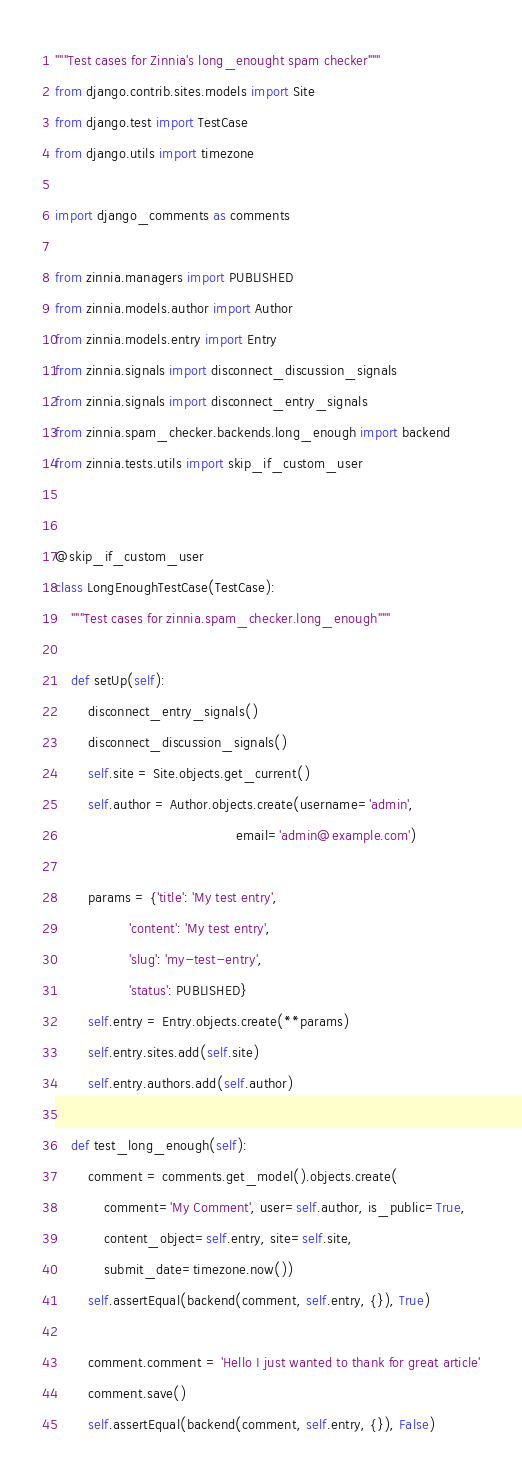Convert code to text. <code><loc_0><loc_0><loc_500><loc_500><_Python_>"""Test cases for Zinnia's long_enought spam checker"""
from django.contrib.sites.models import Site
from django.test import TestCase
from django.utils import timezone

import django_comments as comments

from zinnia.managers import PUBLISHED
from zinnia.models.author import Author
from zinnia.models.entry import Entry
from zinnia.signals import disconnect_discussion_signals
from zinnia.signals import disconnect_entry_signals
from zinnia.spam_checker.backends.long_enough import backend
from zinnia.tests.utils import skip_if_custom_user


@skip_if_custom_user
class LongEnoughTestCase(TestCase):
    """Test cases for zinnia.spam_checker.long_enough"""

    def setUp(self):
        disconnect_entry_signals()
        disconnect_discussion_signals()
        self.site = Site.objects.get_current()
        self.author = Author.objects.create(username='admin',
                                            email='admin@example.com')

        params = {'title': 'My test entry',
                  'content': 'My test entry',
                  'slug': 'my-test-entry',
                  'status': PUBLISHED}
        self.entry = Entry.objects.create(**params)
        self.entry.sites.add(self.site)
        self.entry.authors.add(self.author)

    def test_long_enough(self):
        comment = comments.get_model().objects.create(
            comment='My Comment', user=self.author, is_public=True,
            content_object=self.entry, site=self.site,
            submit_date=timezone.now())
        self.assertEqual(backend(comment, self.entry, {}), True)

        comment.comment = 'Hello I just wanted to thank for great article'
        comment.save()
        self.assertEqual(backend(comment, self.entry, {}), False)
</code> 